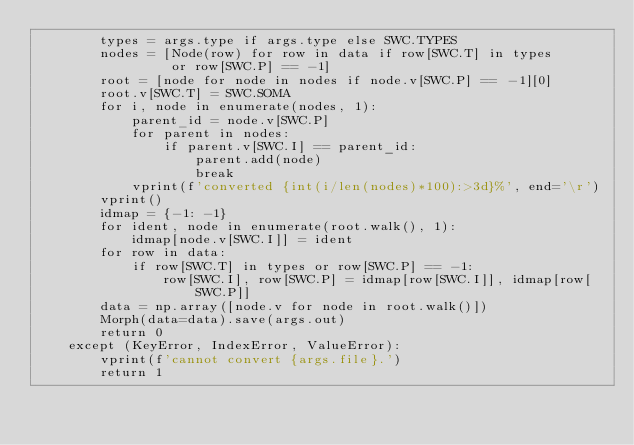<code> <loc_0><loc_0><loc_500><loc_500><_Python_>        types = args.type if args.type else SWC.TYPES
        nodes = [Node(row) for row in data if row[SWC.T] in types
                 or row[SWC.P] == -1]
        root = [node for node in nodes if node.v[SWC.P] == -1][0]
        root.v[SWC.T] = SWC.SOMA
        for i, node in enumerate(nodes, 1):
            parent_id = node.v[SWC.P]
            for parent in nodes:
                if parent.v[SWC.I] == parent_id:
                    parent.add(node)
                    break
            vprint(f'converted {int(i/len(nodes)*100):>3d}%', end='\r')
        vprint()
        idmap = {-1: -1}
        for ident, node in enumerate(root.walk(), 1):
            idmap[node.v[SWC.I]] = ident
        for row in data:
            if row[SWC.T] in types or row[SWC.P] == -1:
                row[SWC.I], row[SWC.P] = idmap[row[SWC.I]], idmap[row[SWC.P]]
        data = np.array([node.v for node in root.walk()])
        Morph(data=data).save(args.out)
        return 0
    except (KeyError, IndexError, ValueError):
        vprint(f'cannot convert {args.file}.')
        return 1
</code> 